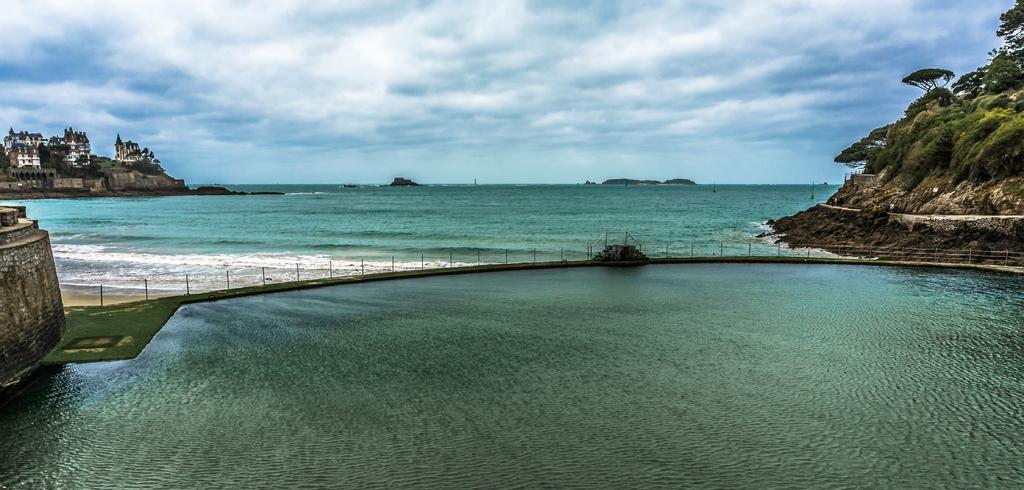Could you give a brief overview of what you see in this image? In this image we can see water, bridge, wall, buildings, trees, and mountain. In the background there is sky with clouds. 